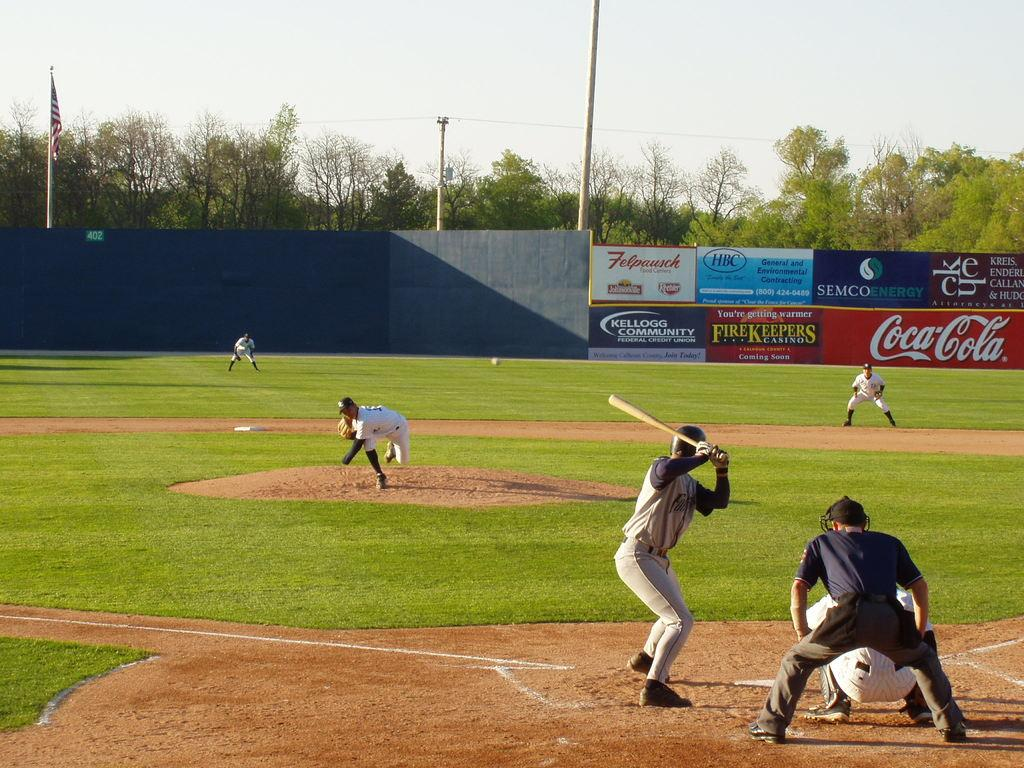Provide a one-sentence caption for the provided image. a baseball game going on with banners on the side that say Coca Cola, Felpausch and more. 